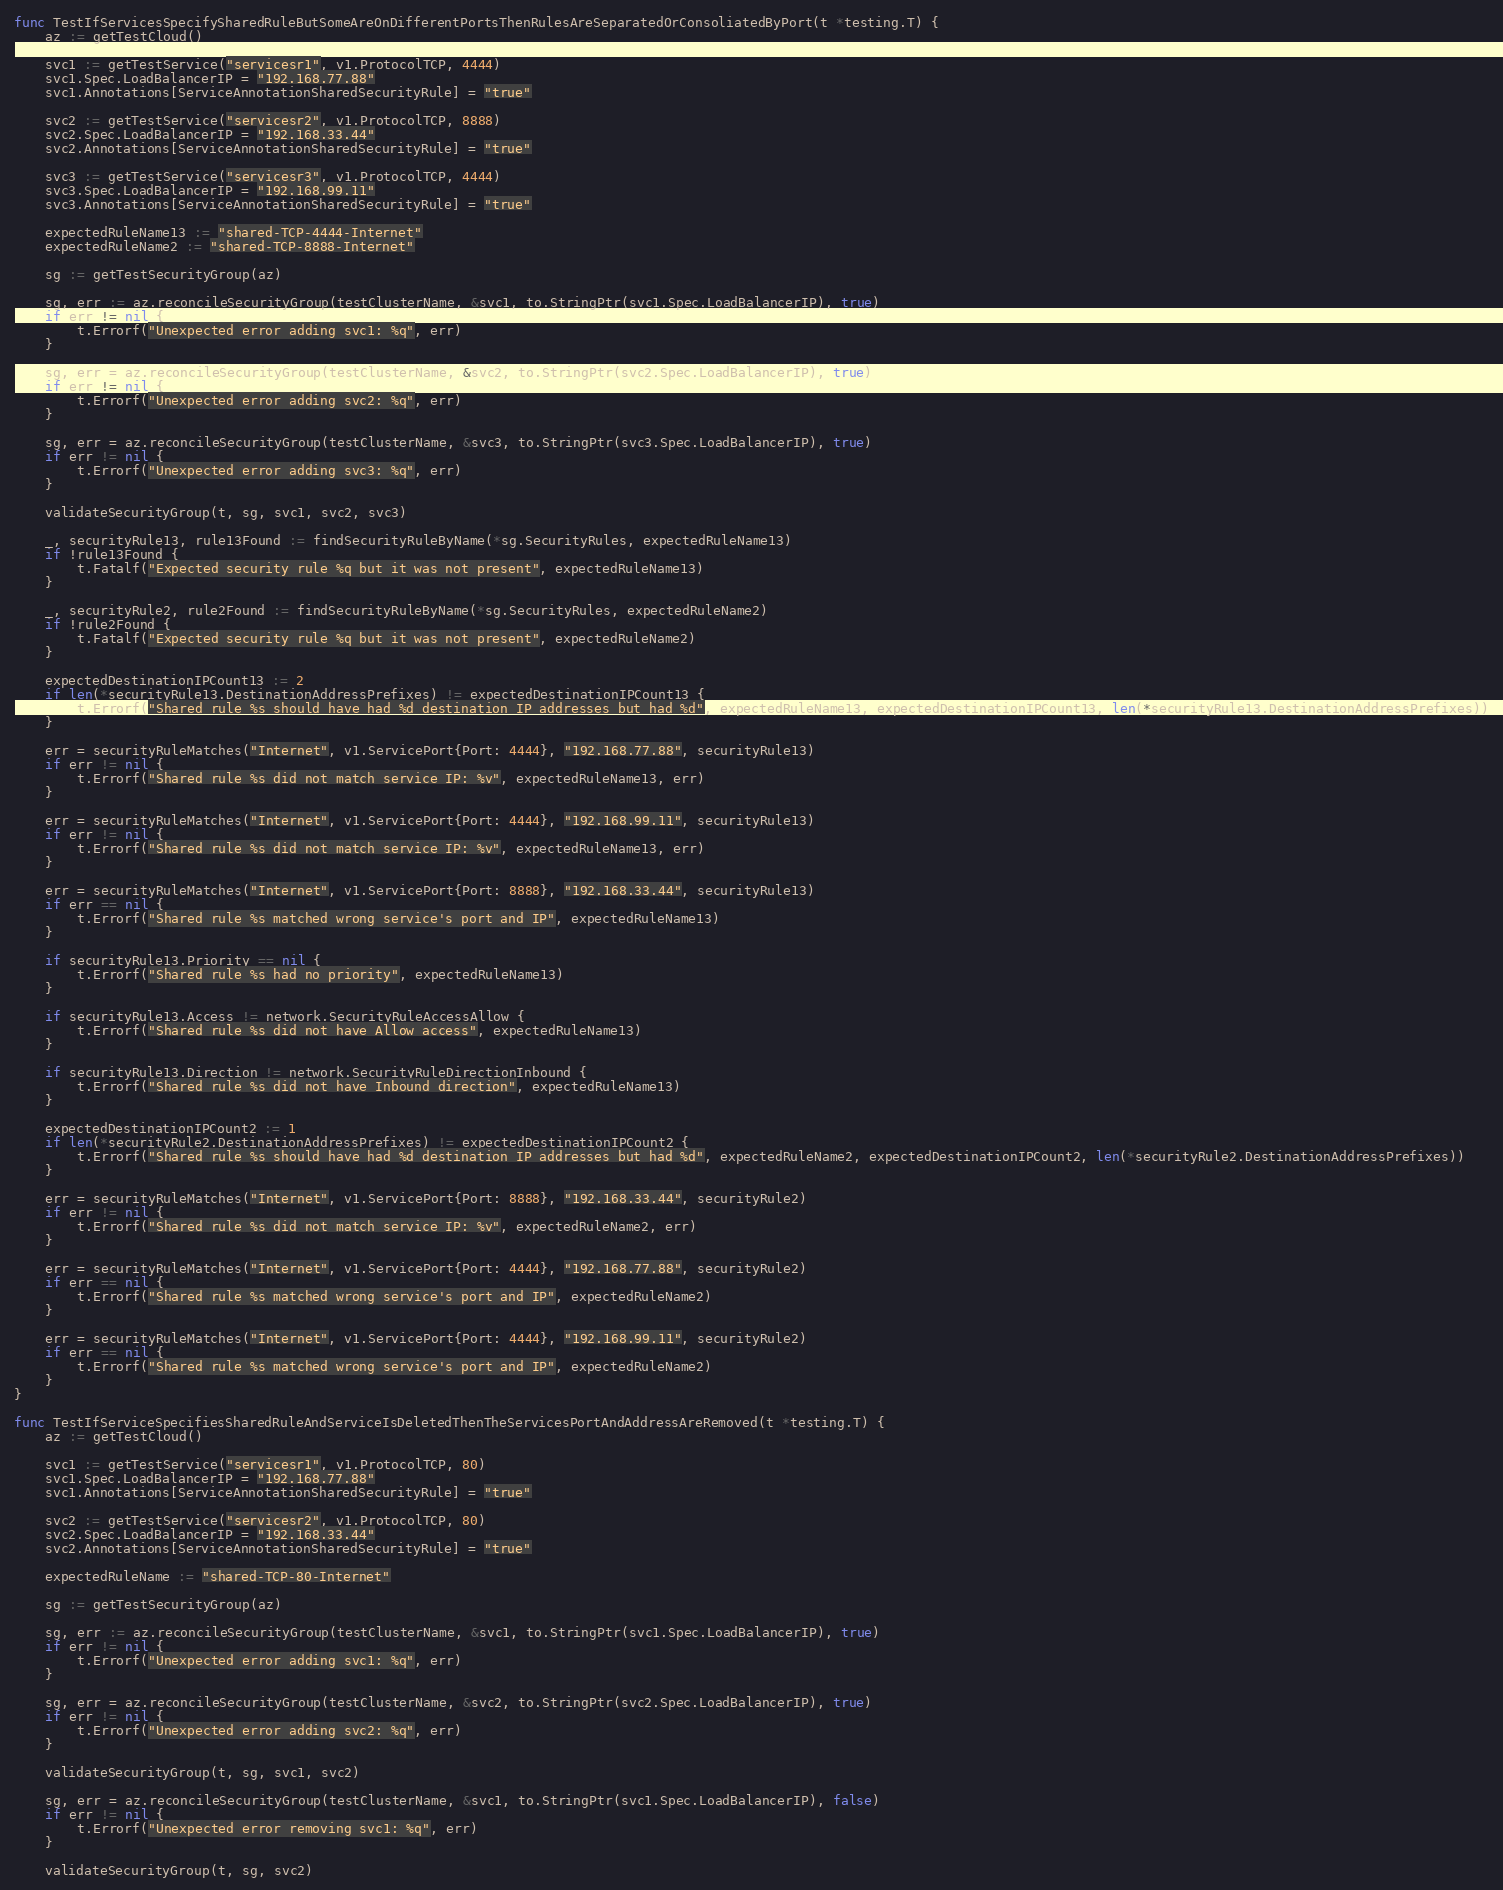<code> <loc_0><loc_0><loc_500><loc_500><_Go_>func TestIfServicesSpecifySharedRuleButSomeAreOnDifferentPortsThenRulesAreSeparatedOrConsoliatedByPort(t *testing.T) {
	az := getTestCloud()

	svc1 := getTestService("servicesr1", v1.ProtocolTCP, 4444)
	svc1.Spec.LoadBalancerIP = "192.168.77.88"
	svc1.Annotations[ServiceAnnotationSharedSecurityRule] = "true"

	svc2 := getTestService("servicesr2", v1.ProtocolTCP, 8888)
	svc2.Spec.LoadBalancerIP = "192.168.33.44"
	svc2.Annotations[ServiceAnnotationSharedSecurityRule] = "true"

	svc3 := getTestService("servicesr3", v1.ProtocolTCP, 4444)
	svc3.Spec.LoadBalancerIP = "192.168.99.11"
	svc3.Annotations[ServiceAnnotationSharedSecurityRule] = "true"

	expectedRuleName13 := "shared-TCP-4444-Internet"
	expectedRuleName2 := "shared-TCP-8888-Internet"

	sg := getTestSecurityGroup(az)

	sg, err := az.reconcileSecurityGroup(testClusterName, &svc1, to.StringPtr(svc1.Spec.LoadBalancerIP), true)
	if err != nil {
		t.Errorf("Unexpected error adding svc1: %q", err)
	}

	sg, err = az.reconcileSecurityGroup(testClusterName, &svc2, to.StringPtr(svc2.Spec.LoadBalancerIP), true)
	if err != nil {
		t.Errorf("Unexpected error adding svc2: %q", err)
	}

	sg, err = az.reconcileSecurityGroup(testClusterName, &svc3, to.StringPtr(svc3.Spec.LoadBalancerIP), true)
	if err != nil {
		t.Errorf("Unexpected error adding svc3: %q", err)
	}

	validateSecurityGroup(t, sg, svc1, svc2, svc3)

	_, securityRule13, rule13Found := findSecurityRuleByName(*sg.SecurityRules, expectedRuleName13)
	if !rule13Found {
		t.Fatalf("Expected security rule %q but it was not present", expectedRuleName13)
	}

	_, securityRule2, rule2Found := findSecurityRuleByName(*sg.SecurityRules, expectedRuleName2)
	if !rule2Found {
		t.Fatalf("Expected security rule %q but it was not present", expectedRuleName2)
	}

	expectedDestinationIPCount13 := 2
	if len(*securityRule13.DestinationAddressPrefixes) != expectedDestinationIPCount13 {
		t.Errorf("Shared rule %s should have had %d destination IP addresses but had %d", expectedRuleName13, expectedDestinationIPCount13, len(*securityRule13.DestinationAddressPrefixes))
	}

	err = securityRuleMatches("Internet", v1.ServicePort{Port: 4444}, "192.168.77.88", securityRule13)
	if err != nil {
		t.Errorf("Shared rule %s did not match service IP: %v", expectedRuleName13, err)
	}

	err = securityRuleMatches("Internet", v1.ServicePort{Port: 4444}, "192.168.99.11", securityRule13)
	if err != nil {
		t.Errorf("Shared rule %s did not match service IP: %v", expectedRuleName13, err)
	}

	err = securityRuleMatches("Internet", v1.ServicePort{Port: 8888}, "192.168.33.44", securityRule13)
	if err == nil {
		t.Errorf("Shared rule %s matched wrong service's port and IP", expectedRuleName13)
	}

	if securityRule13.Priority == nil {
		t.Errorf("Shared rule %s had no priority", expectedRuleName13)
	}

	if securityRule13.Access != network.SecurityRuleAccessAllow {
		t.Errorf("Shared rule %s did not have Allow access", expectedRuleName13)
	}

	if securityRule13.Direction != network.SecurityRuleDirectionInbound {
		t.Errorf("Shared rule %s did not have Inbound direction", expectedRuleName13)
	}

	expectedDestinationIPCount2 := 1
	if len(*securityRule2.DestinationAddressPrefixes) != expectedDestinationIPCount2 {
		t.Errorf("Shared rule %s should have had %d destination IP addresses but had %d", expectedRuleName2, expectedDestinationIPCount2, len(*securityRule2.DestinationAddressPrefixes))
	}

	err = securityRuleMatches("Internet", v1.ServicePort{Port: 8888}, "192.168.33.44", securityRule2)
	if err != nil {
		t.Errorf("Shared rule %s did not match service IP: %v", expectedRuleName2, err)
	}

	err = securityRuleMatches("Internet", v1.ServicePort{Port: 4444}, "192.168.77.88", securityRule2)
	if err == nil {
		t.Errorf("Shared rule %s matched wrong service's port and IP", expectedRuleName2)
	}

	err = securityRuleMatches("Internet", v1.ServicePort{Port: 4444}, "192.168.99.11", securityRule2)
	if err == nil {
		t.Errorf("Shared rule %s matched wrong service's port and IP", expectedRuleName2)
	}
}

func TestIfServiceSpecifiesSharedRuleAndServiceIsDeletedThenTheServicesPortAndAddressAreRemoved(t *testing.T) {
	az := getTestCloud()

	svc1 := getTestService("servicesr1", v1.ProtocolTCP, 80)
	svc1.Spec.LoadBalancerIP = "192.168.77.88"
	svc1.Annotations[ServiceAnnotationSharedSecurityRule] = "true"

	svc2 := getTestService("servicesr2", v1.ProtocolTCP, 80)
	svc2.Spec.LoadBalancerIP = "192.168.33.44"
	svc2.Annotations[ServiceAnnotationSharedSecurityRule] = "true"

	expectedRuleName := "shared-TCP-80-Internet"

	sg := getTestSecurityGroup(az)

	sg, err := az.reconcileSecurityGroup(testClusterName, &svc1, to.StringPtr(svc1.Spec.LoadBalancerIP), true)
	if err != nil {
		t.Errorf("Unexpected error adding svc1: %q", err)
	}

	sg, err = az.reconcileSecurityGroup(testClusterName, &svc2, to.StringPtr(svc2.Spec.LoadBalancerIP), true)
	if err != nil {
		t.Errorf("Unexpected error adding svc2: %q", err)
	}

	validateSecurityGroup(t, sg, svc1, svc2)

	sg, err = az.reconcileSecurityGroup(testClusterName, &svc1, to.StringPtr(svc1.Spec.LoadBalancerIP), false)
	if err != nil {
		t.Errorf("Unexpected error removing svc1: %q", err)
	}

	validateSecurityGroup(t, sg, svc2)
</code> 